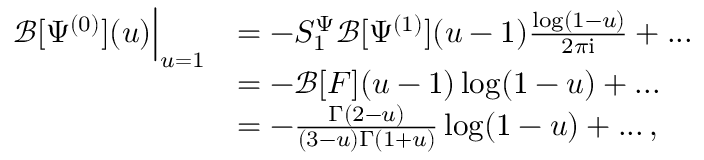Convert formula to latex. <formula><loc_0><loc_0><loc_500><loc_500>\begin{array} { r l } { \mathcal { B } [ \Psi ^ { ( 0 ) } ] ( u ) \Big | _ { u = 1 } } & { = - S _ { 1 } ^ { \Psi } \mathcal { B } [ \Psi ^ { ( 1 ) } ] ( u - 1 ) \frac { \log ( 1 - u ) } { 2 \pi i } + \dots } \\ & { = - \mathcal { B } [ F ] ( u - 1 ) \log ( 1 - u ) + \dots } \\ & { = - \frac { \Gamma ( 2 - u ) } { ( 3 - u ) \Gamma ( 1 + u ) } \log ( 1 - u ) + \dots \, , } \end{array}</formula> 